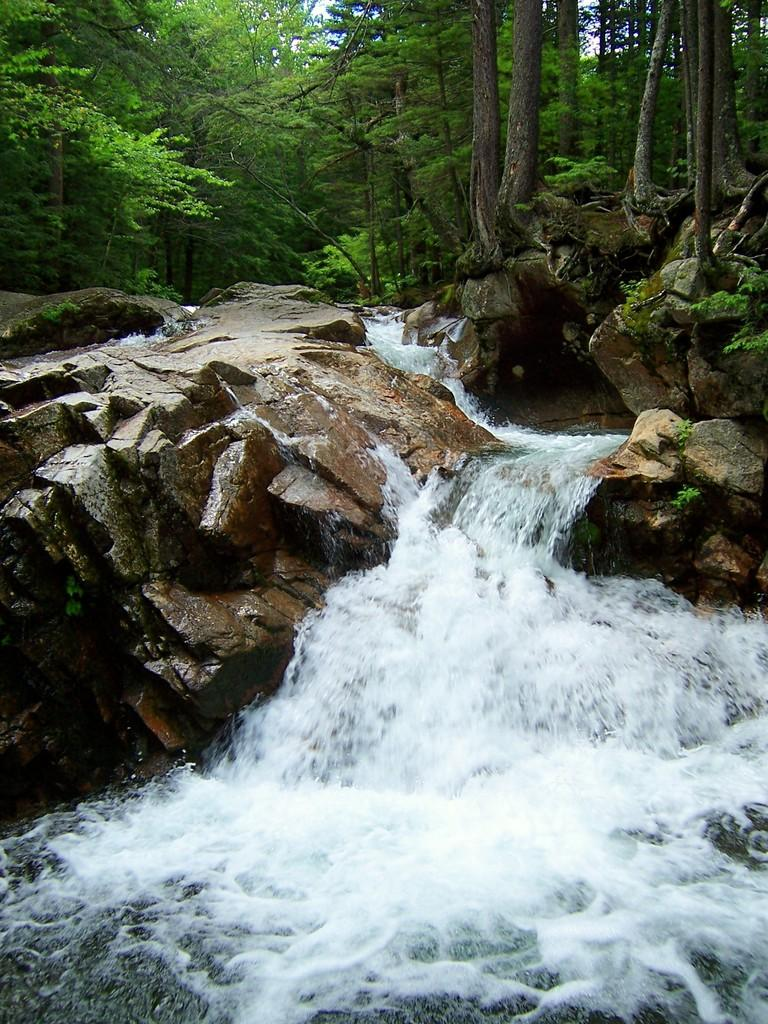What natural feature is the main subject of the image? There is a waterfall in the image. What type of geological feature can be seen in the image? There are stones visible in the image. What type of vegetation is present in the image? There are trees in the image. What is visible in the background of the image? The sky is visible in the image. What type of lock can be seen securing the waterfall in the image? There is no lock present in the image; the waterfall is a natural feature and not secured by any lock. 